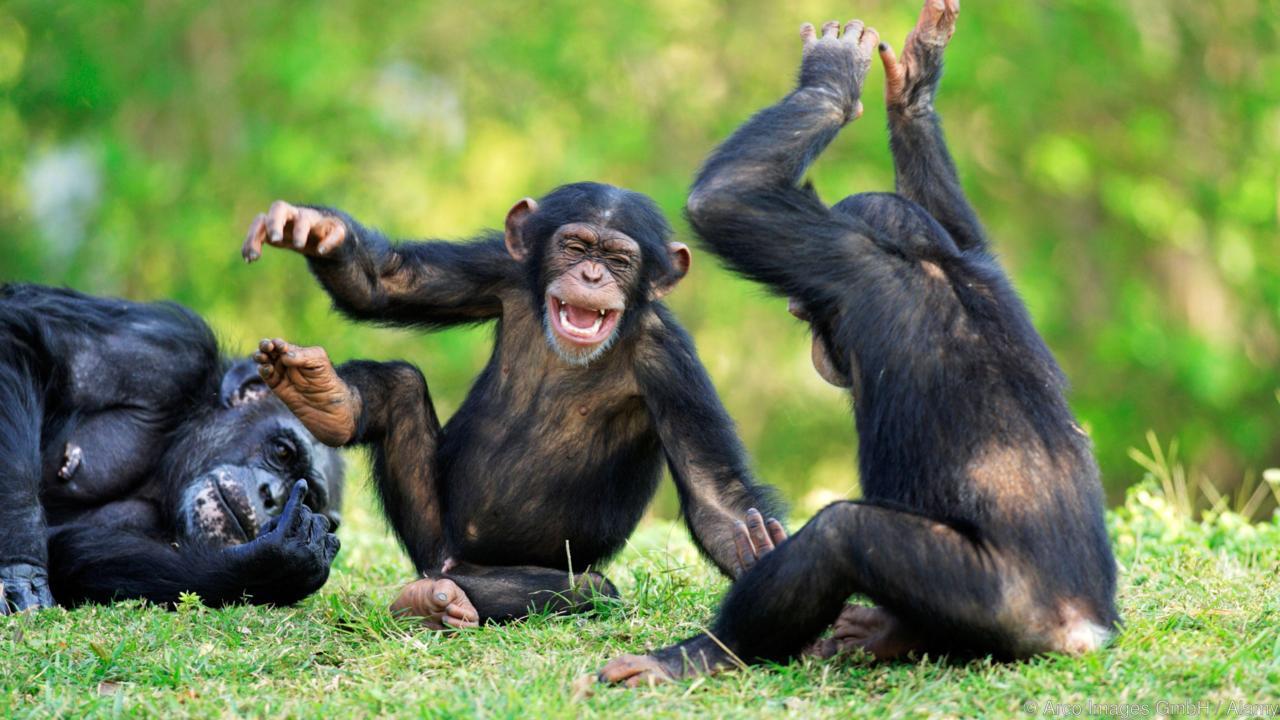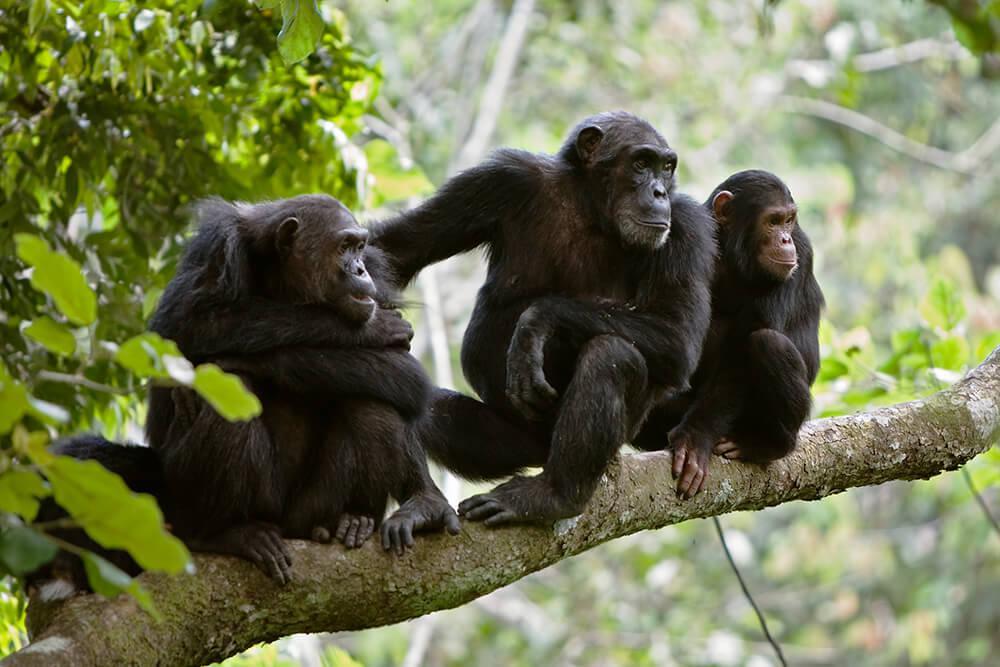The first image is the image on the left, the second image is the image on the right. Considering the images on both sides, is "There is atleast one extremely small baby monkey sitting next to a bigger adult sized monkey." valid? Answer yes or no. No. 